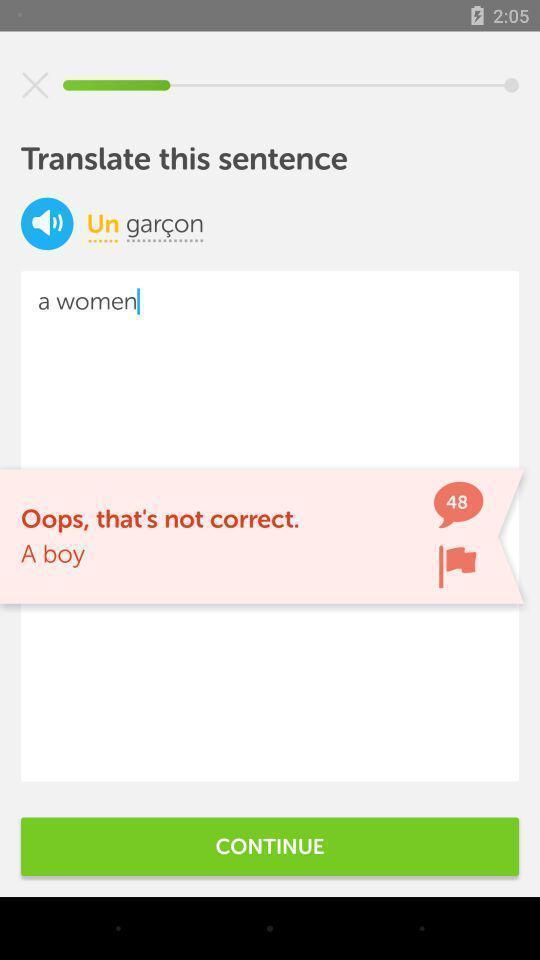Please provide a description for this image. Translation page of a language learning app. 